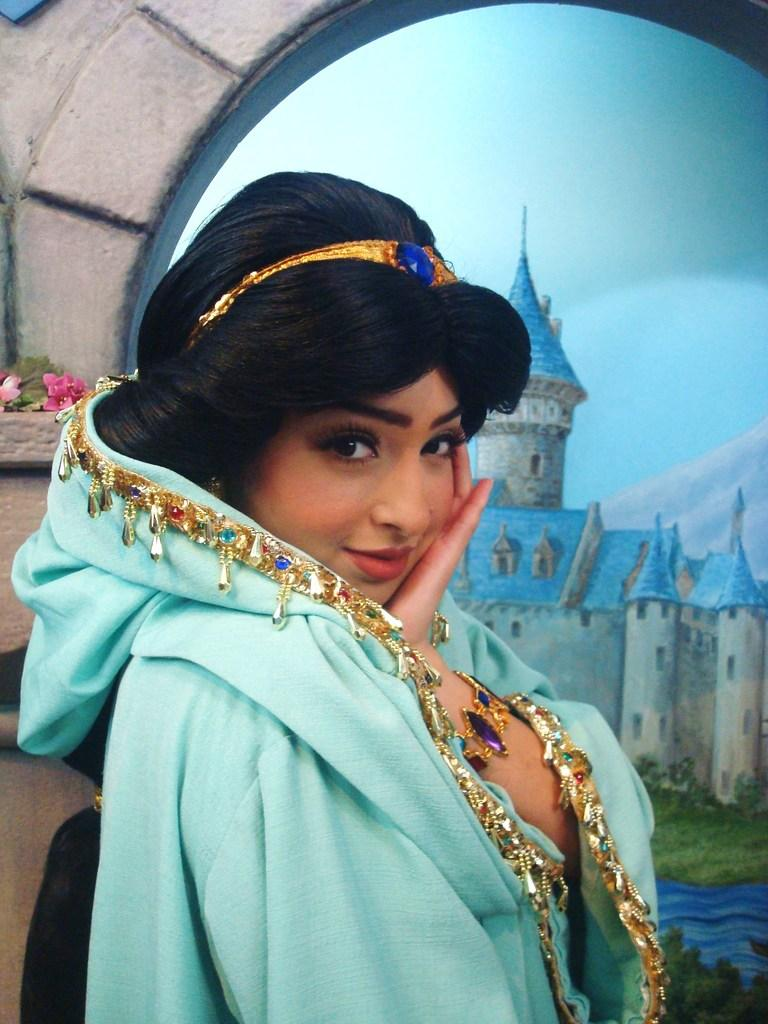Who is present in the image? There is a woman in the image. What is the woman wearing? The woman is wearing clothes. What is the woman's facial expression in the image? The woman is smiling. What can be seen in the painting within the image? The painting contains a building, grass, water, and the sky. What type of fang can be seen in the woman's mouth in the image? There is no fang visible in the woman's mouth in the image. What type of underwear is the woman wearing in the image? The provided facts do not mention the type of underwear the woman is wearing, and it is not visible in the image. 